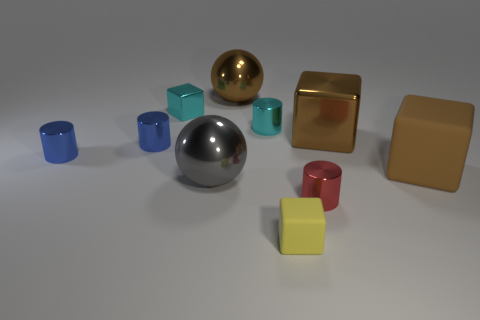How many brown cubes must be subtracted to get 1 brown cubes? 1 Subtract all cyan spheres. Subtract all purple cylinders. How many spheres are left? 2 Subtract all blocks. How many objects are left? 6 Add 6 large gray objects. How many large gray objects are left? 7 Add 9 tiny rubber blocks. How many tiny rubber blocks exist? 10 Subtract 0 brown cylinders. How many objects are left? 10 Subtract all brown spheres. Subtract all large brown rubber things. How many objects are left? 8 